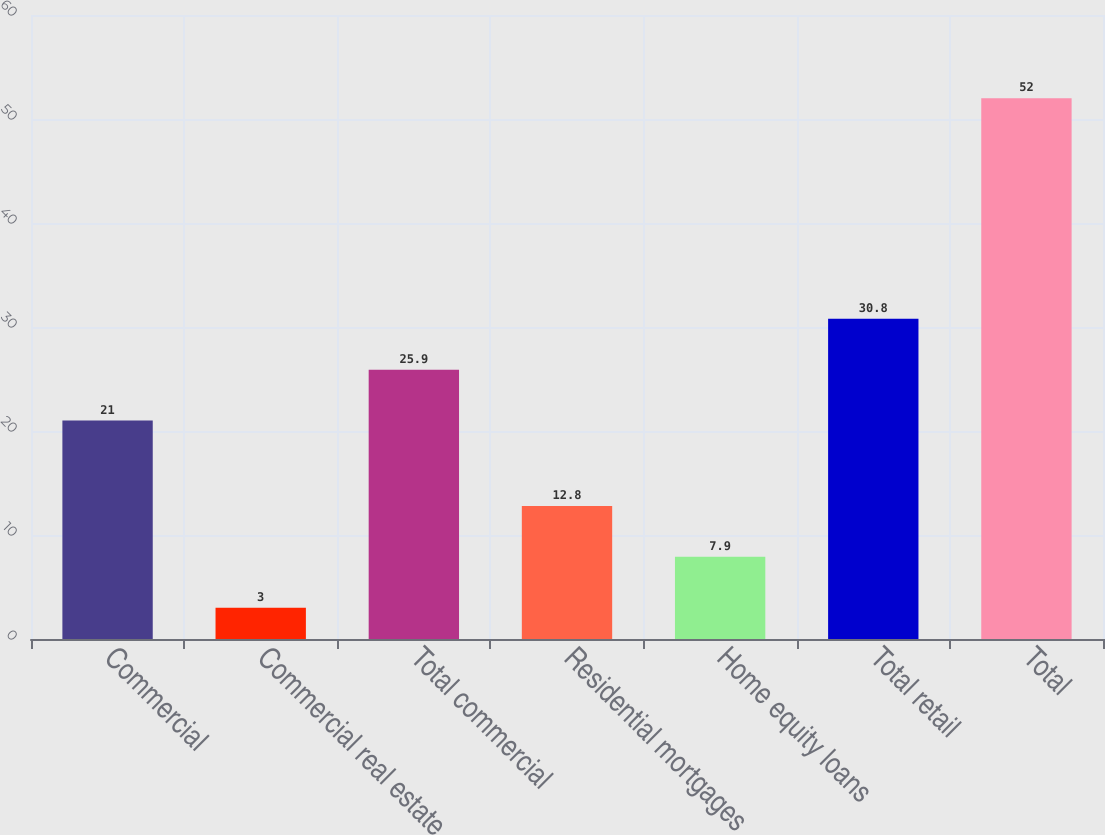Convert chart to OTSL. <chart><loc_0><loc_0><loc_500><loc_500><bar_chart><fcel>Commercial<fcel>Commercial real estate<fcel>Total commercial<fcel>Residential mortgages<fcel>Home equity loans<fcel>Total retail<fcel>Total<nl><fcel>21<fcel>3<fcel>25.9<fcel>12.8<fcel>7.9<fcel>30.8<fcel>52<nl></chart> 